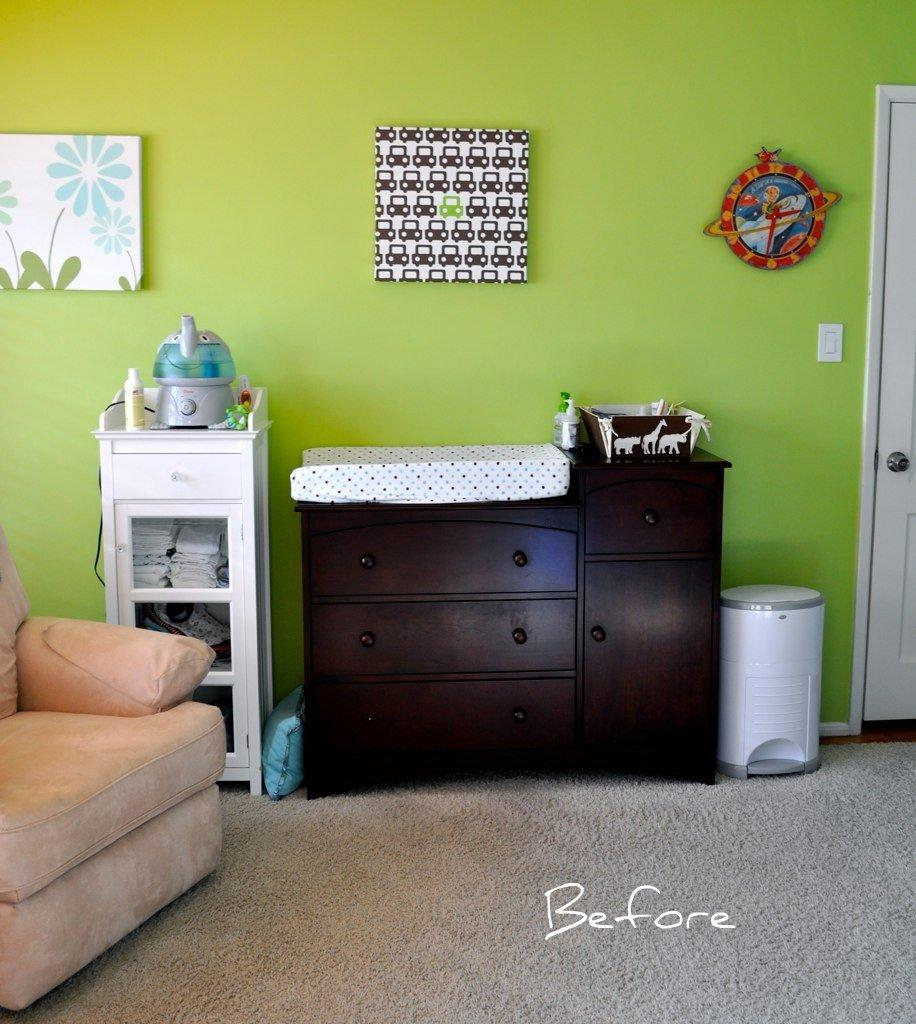<image>
Render a clear and concise summary of the photo. A before picture of a dresser set against a green wall. 